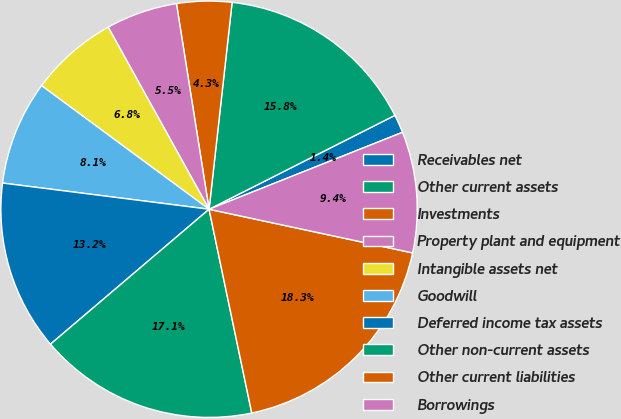<chart> <loc_0><loc_0><loc_500><loc_500><pie_chart><fcel>Receivables net<fcel>Other current assets<fcel>Investments<fcel>Property plant and equipment<fcel>Intangible assets net<fcel>Goodwill<fcel>Deferred income tax assets<fcel>Other non-current assets<fcel>Other current liabilities<fcel>Borrowings<nl><fcel>1.42%<fcel>15.79%<fcel>4.27%<fcel>5.55%<fcel>6.83%<fcel>8.11%<fcel>13.23%<fcel>17.07%<fcel>18.35%<fcel>9.39%<nl></chart> 